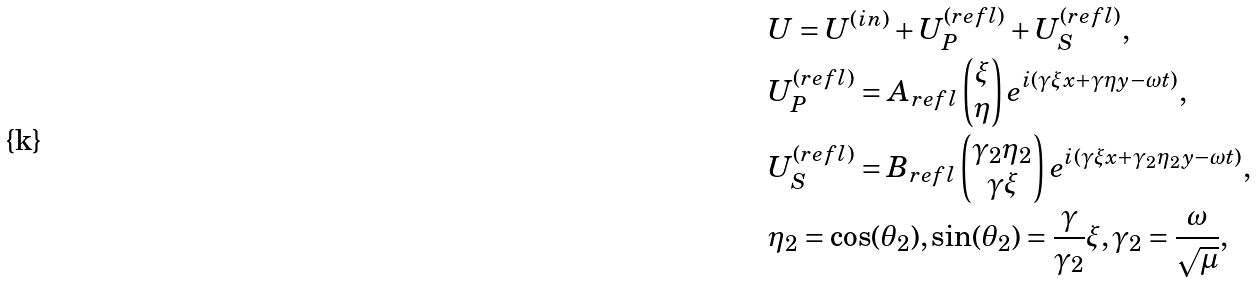Convert formula to latex. <formula><loc_0><loc_0><loc_500><loc_500>& U = U ^ { ( i n ) } + U ^ { ( r e f l ) } _ { P } + U ^ { ( r e f l ) } _ { S } , \\ & U ^ { ( r e f l ) } _ { P } = A _ { r e f l } \begin{pmatrix} \xi \\ \eta \end{pmatrix} e ^ { i ( \gamma \xi x + \gamma \eta y - \omega t ) } , \\ & U ^ { ( r e f l ) } _ { S } = B _ { r e f l } \begin{pmatrix} \gamma _ { 2 } \eta _ { 2 } \\ \gamma \xi \end{pmatrix} e ^ { i ( \gamma \xi x + \gamma _ { 2 } \eta _ { 2 } y - \omega t ) } , \\ & \eta _ { 2 } = \cos ( \theta _ { 2 } ) , \sin ( \theta _ { 2 } ) = \frac { \gamma } { \gamma _ { 2 } } \xi , \gamma _ { 2 } = \frac { \omega } { \sqrt { \mu } } ,</formula> 